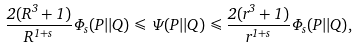Convert formula to latex. <formula><loc_0><loc_0><loc_500><loc_500>\frac { 2 ( R ^ { 3 } + 1 ) } { R ^ { 1 + s } } \Phi _ { s } ( P | | Q ) \leqslant \Psi ( P | | Q ) \leqslant \frac { 2 ( r ^ { 3 } + 1 ) } { r ^ { 1 + s } } \Phi _ { s } ( P | | Q ) ,</formula> 